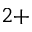Convert formula to latex. <formula><loc_0><loc_0><loc_500><loc_500>^ { 2 + }</formula> 